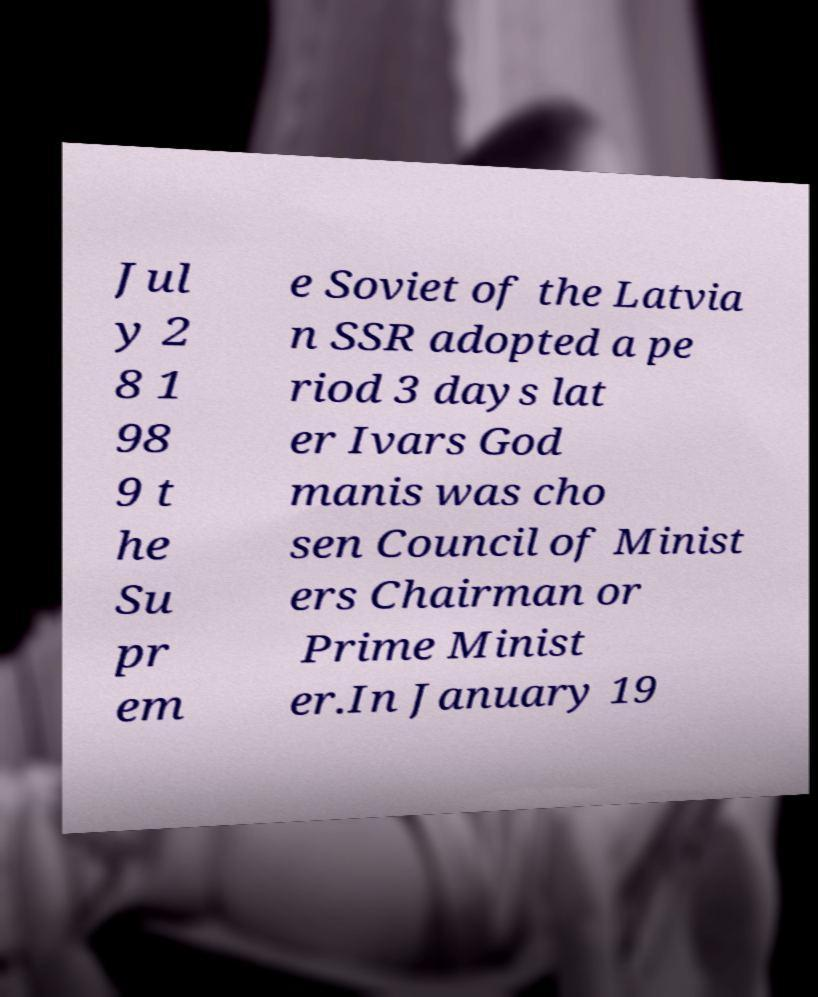Please identify and transcribe the text found in this image. Jul y 2 8 1 98 9 t he Su pr em e Soviet of the Latvia n SSR adopted a pe riod 3 days lat er Ivars God manis was cho sen Council of Minist ers Chairman or Prime Minist er.In January 19 